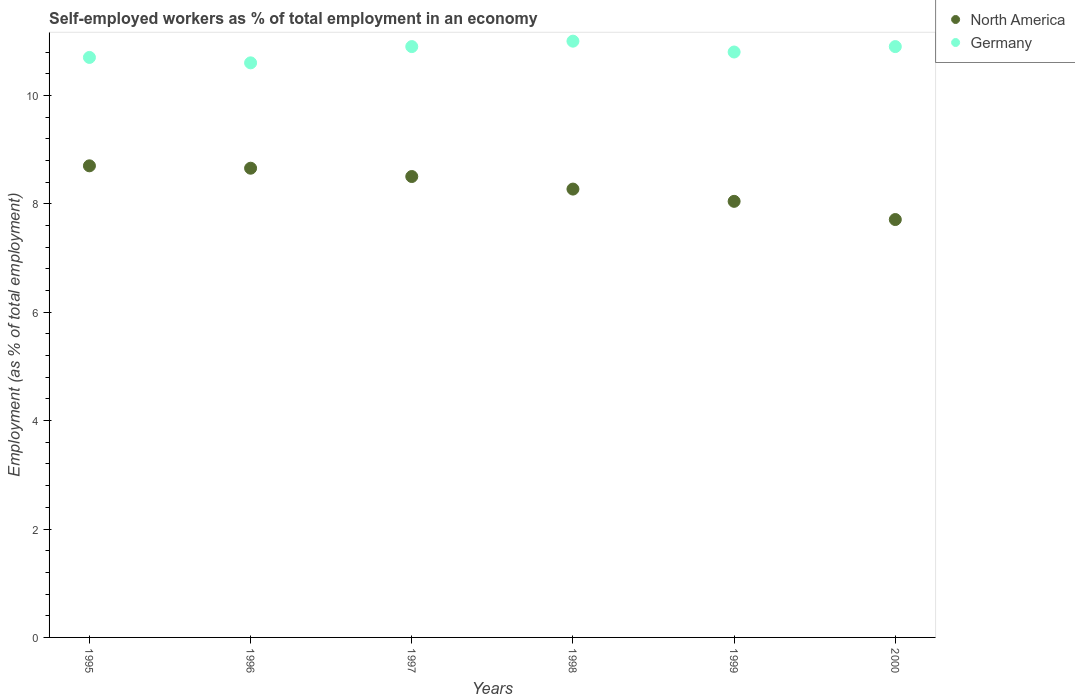How many different coloured dotlines are there?
Give a very brief answer. 2. What is the percentage of self-employed workers in Germany in 1997?
Your answer should be compact. 10.9. Across all years, what is the maximum percentage of self-employed workers in North America?
Your response must be concise. 8.7. Across all years, what is the minimum percentage of self-employed workers in Germany?
Your answer should be very brief. 10.6. In which year was the percentage of self-employed workers in Germany minimum?
Your response must be concise. 1996. What is the total percentage of self-employed workers in North America in the graph?
Your answer should be very brief. 49.89. What is the difference between the percentage of self-employed workers in North America in 1997 and that in 1999?
Make the answer very short. 0.46. What is the difference between the percentage of self-employed workers in North America in 1998 and the percentage of self-employed workers in Germany in 1997?
Give a very brief answer. -2.63. What is the average percentage of self-employed workers in North America per year?
Make the answer very short. 8.31. In the year 1995, what is the difference between the percentage of self-employed workers in Germany and percentage of self-employed workers in North America?
Ensure brevity in your answer.  2. In how many years, is the percentage of self-employed workers in North America greater than 1.6 %?
Make the answer very short. 6. What is the ratio of the percentage of self-employed workers in North America in 1998 to that in 1999?
Give a very brief answer. 1.03. Is the difference between the percentage of self-employed workers in Germany in 1995 and 2000 greater than the difference between the percentage of self-employed workers in North America in 1995 and 2000?
Ensure brevity in your answer.  No. What is the difference between the highest and the second highest percentage of self-employed workers in Germany?
Provide a short and direct response. 0.1. What is the difference between the highest and the lowest percentage of self-employed workers in Germany?
Give a very brief answer. 0.4. Is the percentage of self-employed workers in North America strictly greater than the percentage of self-employed workers in Germany over the years?
Ensure brevity in your answer.  No. Is the percentage of self-employed workers in Germany strictly less than the percentage of self-employed workers in North America over the years?
Keep it short and to the point. No. How many dotlines are there?
Ensure brevity in your answer.  2. How many years are there in the graph?
Keep it short and to the point. 6. Are the values on the major ticks of Y-axis written in scientific E-notation?
Your response must be concise. No. Where does the legend appear in the graph?
Make the answer very short. Top right. How many legend labels are there?
Make the answer very short. 2. How are the legend labels stacked?
Keep it short and to the point. Vertical. What is the title of the graph?
Your response must be concise. Self-employed workers as % of total employment in an economy. Does "Kazakhstan" appear as one of the legend labels in the graph?
Keep it short and to the point. No. What is the label or title of the X-axis?
Your answer should be compact. Years. What is the label or title of the Y-axis?
Ensure brevity in your answer.  Employment (as % of total employment). What is the Employment (as % of total employment) in North America in 1995?
Offer a very short reply. 8.7. What is the Employment (as % of total employment) in Germany in 1995?
Provide a short and direct response. 10.7. What is the Employment (as % of total employment) in North America in 1996?
Your answer should be very brief. 8.66. What is the Employment (as % of total employment) in Germany in 1996?
Ensure brevity in your answer.  10.6. What is the Employment (as % of total employment) in North America in 1997?
Make the answer very short. 8.5. What is the Employment (as % of total employment) of Germany in 1997?
Offer a terse response. 10.9. What is the Employment (as % of total employment) of North America in 1998?
Your response must be concise. 8.27. What is the Employment (as % of total employment) in North America in 1999?
Your response must be concise. 8.04. What is the Employment (as % of total employment) in Germany in 1999?
Keep it short and to the point. 10.8. What is the Employment (as % of total employment) in North America in 2000?
Your response must be concise. 7.71. What is the Employment (as % of total employment) of Germany in 2000?
Make the answer very short. 10.9. Across all years, what is the maximum Employment (as % of total employment) in North America?
Provide a succinct answer. 8.7. Across all years, what is the maximum Employment (as % of total employment) in Germany?
Offer a very short reply. 11. Across all years, what is the minimum Employment (as % of total employment) of North America?
Your answer should be compact. 7.71. Across all years, what is the minimum Employment (as % of total employment) in Germany?
Keep it short and to the point. 10.6. What is the total Employment (as % of total employment) in North America in the graph?
Ensure brevity in your answer.  49.88. What is the total Employment (as % of total employment) of Germany in the graph?
Your answer should be very brief. 64.9. What is the difference between the Employment (as % of total employment) in North America in 1995 and that in 1996?
Make the answer very short. 0.04. What is the difference between the Employment (as % of total employment) of North America in 1995 and that in 1997?
Provide a succinct answer. 0.2. What is the difference between the Employment (as % of total employment) in North America in 1995 and that in 1998?
Provide a succinct answer. 0.43. What is the difference between the Employment (as % of total employment) in Germany in 1995 and that in 1998?
Offer a terse response. -0.3. What is the difference between the Employment (as % of total employment) in North America in 1995 and that in 1999?
Your answer should be compact. 0.66. What is the difference between the Employment (as % of total employment) of North America in 1995 and that in 2000?
Your response must be concise. 0.99. What is the difference between the Employment (as % of total employment) of Germany in 1995 and that in 2000?
Make the answer very short. -0.2. What is the difference between the Employment (as % of total employment) of North America in 1996 and that in 1997?
Offer a terse response. 0.15. What is the difference between the Employment (as % of total employment) in Germany in 1996 and that in 1997?
Offer a terse response. -0.3. What is the difference between the Employment (as % of total employment) of North America in 1996 and that in 1998?
Offer a terse response. 0.38. What is the difference between the Employment (as % of total employment) in North America in 1996 and that in 1999?
Make the answer very short. 0.61. What is the difference between the Employment (as % of total employment) of Germany in 1996 and that in 1999?
Provide a short and direct response. -0.2. What is the difference between the Employment (as % of total employment) of North America in 1996 and that in 2000?
Your answer should be very brief. 0.95. What is the difference between the Employment (as % of total employment) of Germany in 1996 and that in 2000?
Offer a very short reply. -0.3. What is the difference between the Employment (as % of total employment) in North America in 1997 and that in 1998?
Offer a terse response. 0.23. What is the difference between the Employment (as % of total employment) in Germany in 1997 and that in 1998?
Your answer should be compact. -0.1. What is the difference between the Employment (as % of total employment) of North America in 1997 and that in 1999?
Your answer should be compact. 0.46. What is the difference between the Employment (as % of total employment) of North America in 1997 and that in 2000?
Your answer should be very brief. 0.79. What is the difference between the Employment (as % of total employment) in Germany in 1997 and that in 2000?
Make the answer very short. 0. What is the difference between the Employment (as % of total employment) in North America in 1998 and that in 1999?
Keep it short and to the point. 0.23. What is the difference between the Employment (as % of total employment) of Germany in 1998 and that in 1999?
Make the answer very short. 0.2. What is the difference between the Employment (as % of total employment) of North America in 1998 and that in 2000?
Your answer should be compact. 0.56. What is the difference between the Employment (as % of total employment) of Germany in 1998 and that in 2000?
Provide a short and direct response. 0.1. What is the difference between the Employment (as % of total employment) in North America in 1999 and that in 2000?
Make the answer very short. 0.34. What is the difference between the Employment (as % of total employment) in North America in 1995 and the Employment (as % of total employment) in Germany in 1996?
Provide a short and direct response. -1.9. What is the difference between the Employment (as % of total employment) of North America in 1995 and the Employment (as % of total employment) of Germany in 1997?
Make the answer very short. -2.2. What is the difference between the Employment (as % of total employment) in North America in 1995 and the Employment (as % of total employment) in Germany in 1998?
Your answer should be very brief. -2.3. What is the difference between the Employment (as % of total employment) in North America in 1995 and the Employment (as % of total employment) in Germany in 1999?
Keep it short and to the point. -2.1. What is the difference between the Employment (as % of total employment) in North America in 1995 and the Employment (as % of total employment) in Germany in 2000?
Offer a very short reply. -2.2. What is the difference between the Employment (as % of total employment) of North America in 1996 and the Employment (as % of total employment) of Germany in 1997?
Your answer should be very brief. -2.24. What is the difference between the Employment (as % of total employment) in North America in 1996 and the Employment (as % of total employment) in Germany in 1998?
Your answer should be very brief. -2.34. What is the difference between the Employment (as % of total employment) in North America in 1996 and the Employment (as % of total employment) in Germany in 1999?
Your answer should be compact. -2.14. What is the difference between the Employment (as % of total employment) in North America in 1996 and the Employment (as % of total employment) in Germany in 2000?
Keep it short and to the point. -2.24. What is the difference between the Employment (as % of total employment) in North America in 1997 and the Employment (as % of total employment) in Germany in 1998?
Provide a succinct answer. -2.5. What is the difference between the Employment (as % of total employment) of North America in 1997 and the Employment (as % of total employment) of Germany in 1999?
Offer a terse response. -2.3. What is the difference between the Employment (as % of total employment) of North America in 1997 and the Employment (as % of total employment) of Germany in 2000?
Your answer should be compact. -2.4. What is the difference between the Employment (as % of total employment) of North America in 1998 and the Employment (as % of total employment) of Germany in 1999?
Give a very brief answer. -2.53. What is the difference between the Employment (as % of total employment) of North America in 1998 and the Employment (as % of total employment) of Germany in 2000?
Ensure brevity in your answer.  -2.63. What is the difference between the Employment (as % of total employment) in North America in 1999 and the Employment (as % of total employment) in Germany in 2000?
Give a very brief answer. -2.85. What is the average Employment (as % of total employment) of North America per year?
Make the answer very short. 8.31. What is the average Employment (as % of total employment) in Germany per year?
Keep it short and to the point. 10.82. In the year 1995, what is the difference between the Employment (as % of total employment) in North America and Employment (as % of total employment) in Germany?
Make the answer very short. -2. In the year 1996, what is the difference between the Employment (as % of total employment) in North America and Employment (as % of total employment) in Germany?
Your answer should be very brief. -1.94. In the year 1997, what is the difference between the Employment (as % of total employment) of North America and Employment (as % of total employment) of Germany?
Your answer should be very brief. -2.4. In the year 1998, what is the difference between the Employment (as % of total employment) in North America and Employment (as % of total employment) in Germany?
Keep it short and to the point. -2.73. In the year 1999, what is the difference between the Employment (as % of total employment) of North America and Employment (as % of total employment) of Germany?
Keep it short and to the point. -2.75. In the year 2000, what is the difference between the Employment (as % of total employment) of North America and Employment (as % of total employment) of Germany?
Provide a succinct answer. -3.19. What is the ratio of the Employment (as % of total employment) of North America in 1995 to that in 1996?
Your answer should be compact. 1.01. What is the ratio of the Employment (as % of total employment) in Germany in 1995 to that in 1996?
Make the answer very short. 1.01. What is the ratio of the Employment (as % of total employment) in North America in 1995 to that in 1997?
Offer a very short reply. 1.02. What is the ratio of the Employment (as % of total employment) of Germany in 1995 to that in 1997?
Give a very brief answer. 0.98. What is the ratio of the Employment (as % of total employment) of North America in 1995 to that in 1998?
Your answer should be compact. 1.05. What is the ratio of the Employment (as % of total employment) in Germany in 1995 to that in 1998?
Offer a very short reply. 0.97. What is the ratio of the Employment (as % of total employment) of North America in 1995 to that in 1999?
Make the answer very short. 1.08. What is the ratio of the Employment (as % of total employment) of North America in 1995 to that in 2000?
Ensure brevity in your answer.  1.13. What is the ratio of the Employment (as % of total employment) of Germany in 1995 to that in 2000?
Offer a very short reply. 0.98. What is the ratio of the Employment (as % of total employment) of North America in 1996 to that in 1997?
Provide a succinct answer. 1.02. What is the ratio of the Employment (as % of total employment) in Germany in 1996 to that in 1997?
Offer a terse response. 0.97. What is the ratio of the Employment (as % of total employment) in North America in 1996 to that in 1998?
Offer a very short reply. 1.05. What is the ratio of the Employment (as % of total employment) in Germany in 1996 to that in 1998?
Ensure brevity in your answer.  0.96. What is the ratio of the Employment (as % of total employment) in North America in 1996 to that in 1999?
Your answer should be very brief. 1.08. What is the ratio of the Employment (as % of total employment) of Germany in 1996 to that in 1999?
Give a very brief answer. 0.98. What is the ratio of the Employment (as % of total employment) of North America in 1996 to that in 2000?
Offer a terse response. 1.12. What is the ratio of the Employment (as % of total employment) of Germany in 1996 to that in 2000?
Provide a short and direct response. 0.97. What is the ratio of the Employment (as % of total employment) of North America in 1997 to that in 1998?
Provide a short and direct response. 1.03. What is the ratio of the Employment (as % of total employment) in Germany in 1997 to that in 1998?
Provide a succinct answer. 0.99. What is the ratio of the Employment (as % of total employment) in North America in 1997 to that in 1999?
Give a very brief answer. 1.06. What is the ratio of the Employment (as % of total employment) of Germany in 1997 to that in 1999?
Give a very brief answer. 1.01. What is the ratio of the Employment (as % of total employment) of North America in 1997 to that in 2000?
Provide a short and direct response. 1.1. What is the ratio of the Employment (as % of total employment) of North America in 1998 to that in 1999?
Keep it short and to the point. 1.03. What is the ratio of the Employment (as % of total employment) of Germany in 1998 to that in 1999?
Provide a short and direct response. 1.02. What is the ratio of the Employment (as % of total employment) of North America in 1998 to that in 2000?
Your answer should be compact. 1.07. What is the ratio of the Employment (as % of total employment) of Germany in 1998 to that in 2000?
Ensure brevity in your answer.  1.01. What is the ratio of the Employment (as % of total employment) in North America in 1999 to that in 2000?
Keep it short and to the point. 1.04. What is the difference between the highest and the second highest Employment (as % of total employment) in North America?
Keep it short and to the point. 0.04. What is the difference between the highest and the lowest Employment (as % of total employment) in North America?
Provide a short and direct response. 0.99. What is the difference between the highest and the lowest Employment (as % of total employment) in Germany?
Offer a terse response. 0.4. 